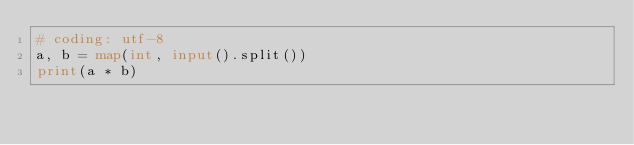Convert code to text. <code><loc_0><loc_0><loc_500><loc_500><_Python_># coding: utf-8
a, b = map(int, input().split())
print(a * b)</code> 